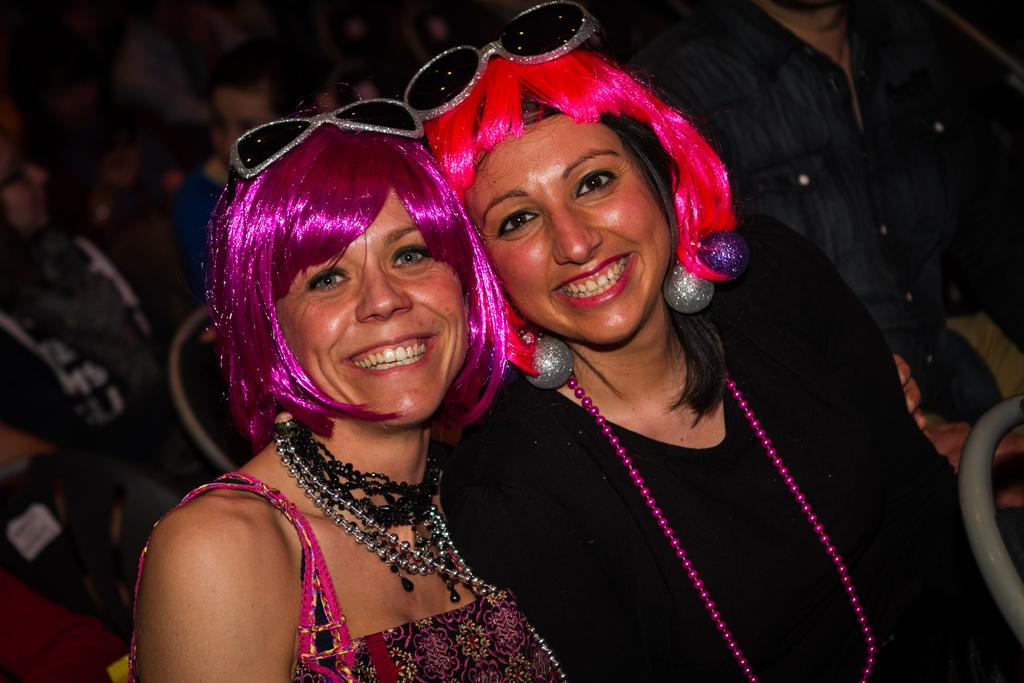How many people are in the image? There are two women in the image. What are the women wearing on their heads? The women are wearing wigs. What expression do the women have in the image? The women are smiling. Can you describe the background of the image? The background of the image is blurred. What type of eggs are being cooked in the kettle in the image? There is no kettle or eggs present in the image. 